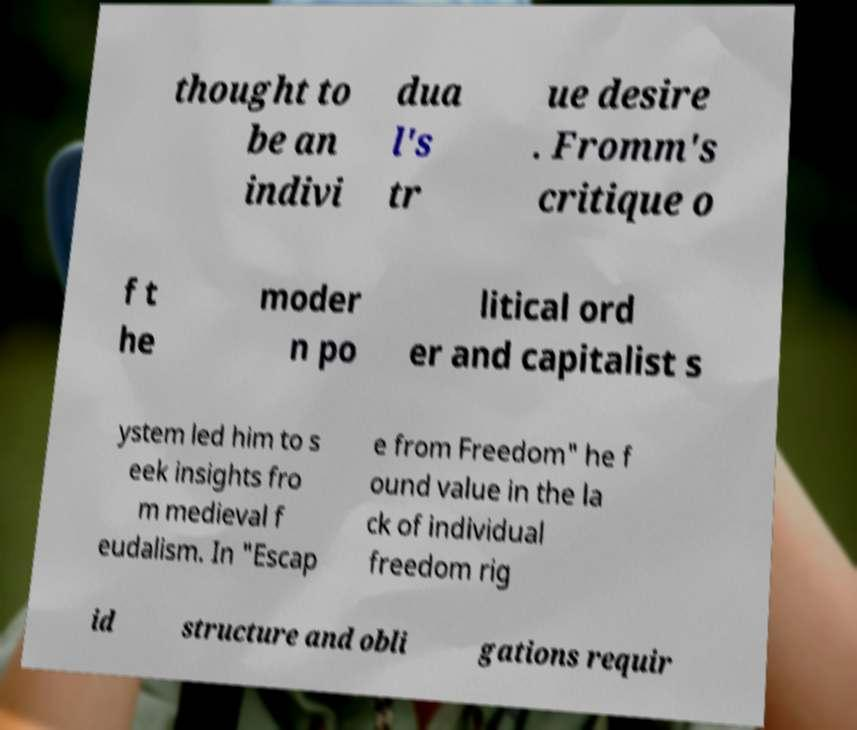Can you read and provide the text displayed in the image?This photo seems to have some interesting text. Can you extract and type it out for me? thought to be an indivi dua l's tr ue desire . Fromm's critique o f t he moder n po litical ord er and capitalist s ystem led him to s eek insights fro m medieval f eudalism. In "Escap e from Freedom" he f ound value in the la ck of individual freedom rig id structure and obli gations requir 